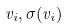Convert formula to latex. <formula><loc_0><loc_0><loc_500><loc_500>v _ { i } , \sigma ( v _ { i } )</formula> 